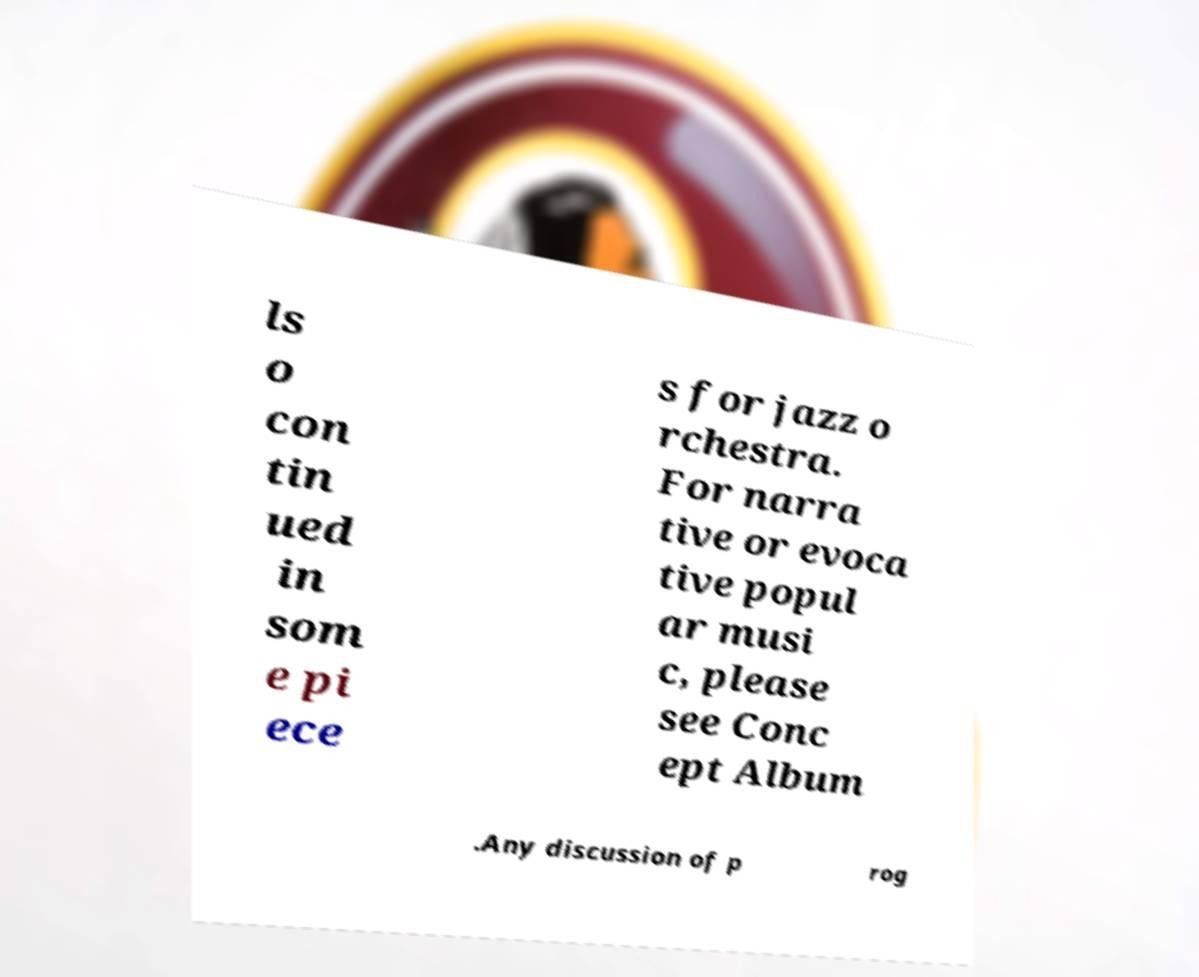There's text embedded in this image that I need extracted. Can you transcribe it verbatim? ls o con tin ued in som e pi ece s for jazz o rchestra. For narra tive or evoca tive popul ar musi c, please see Conc ept Album .Any discussion of p rog 